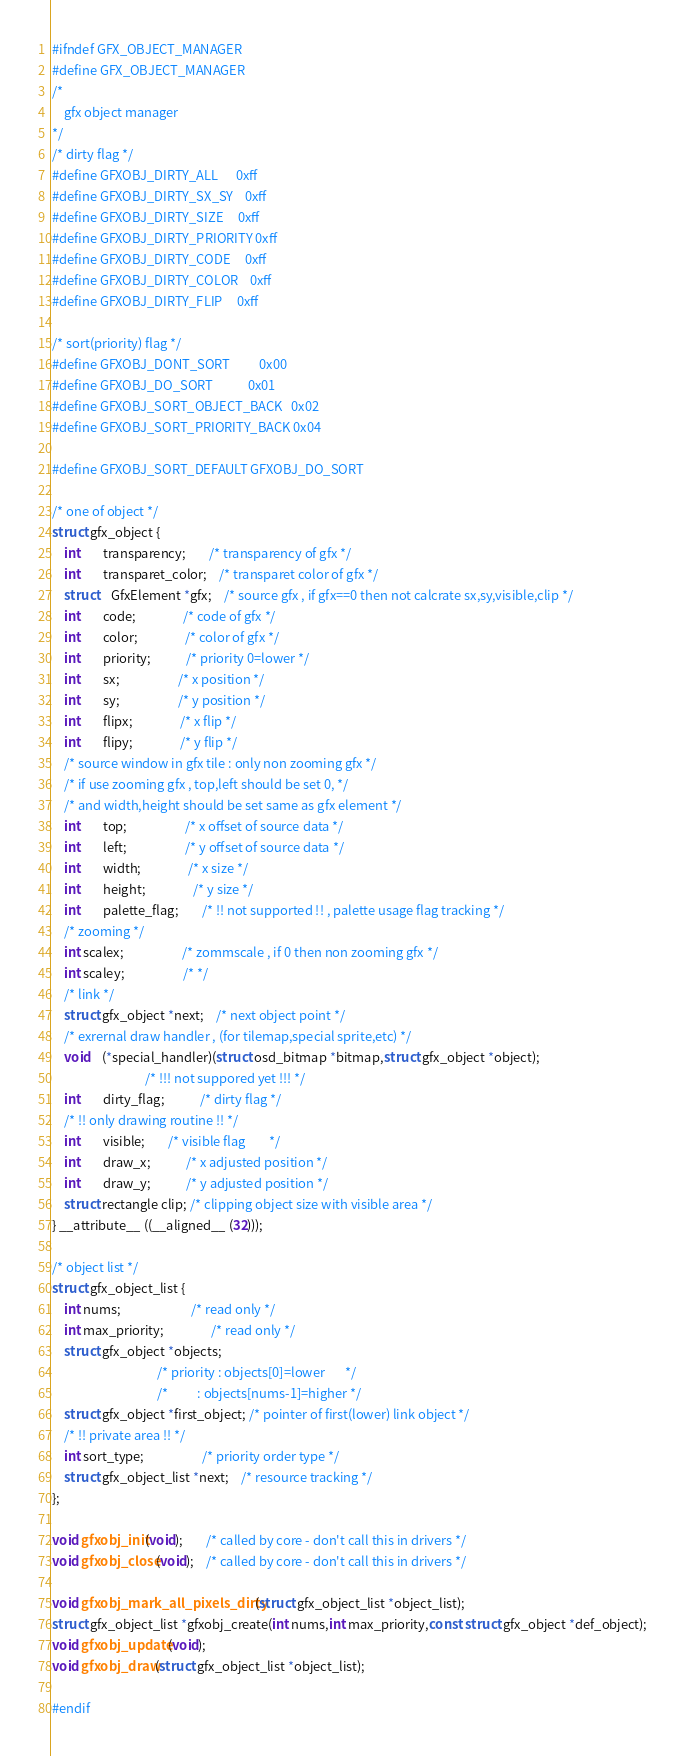Convert code to text. <code><loc_0><loc_0><loc_500><loc_500><_C_>#ifndef GFX_OBJECT_MANAGER
#define GFX_OBJECT_MANAGER
/*
	gfx object manager
*/
/* dirty flag */
#define GFXOBJ_DIRTY_ALL      0xff
#define GFXOBJ_DIRTY_SX_SY    0xff
#define GFXOBJ_DIRTY_SIZE     0xff
#define GFXOBJ_DIRTY_PRIORITY 0xff
#define GFXOBJ_DIRTY_CODE     0xff
#define GFXOBJ_DIRTY_COLOR    0xff
#define GFXOBJ_DIRTY_FLIP     0xff

/* sort(priority) flag */
#define GFXOBJ_DONT_SORT          0x00
#define GFXOBJ_DO_SORT            0x01
#define GFXOBJ_SORT_OBJECT_BACK   0x02
#define GFXOBJ_SORT_PRIORITY_BACK 0x04

#define GFXOBJ_SORT_DEFAULT GFXOBJ_DO_SORT

/* one of object */
struct gfx_object {
	int		transparency;		/* transparency of gfx */
	int		transparet_color;	/* transparet color of gfx */
	struct	GfxElement *gfx;	/* source gfx , if gfx==0 then not calcrate sx,sy,visible,clip */
	int		code;				/* code of gfx */
	int		color;				/* color of gfx */
	int		priority;			/* priority 0=lower */
	int		sx;					/* x position */
	int		sy;					/* y position */
	int		flipx;				/* x flip */
	int		flipy;				/* y flip */
	/* source window in gfx tile : only non zooming gfx */
	/* if use zooming gfx , top,left should be set 0, */
	/* and width,height should be set same as gfx element */
	int		top;					/* x offset of source data */
	int		left;					/* y offset of source data */
	int		width;				/* x size */
	int		height;				/* y size */
	int		palette_flag;		/* !! not supported !! , palette usage flag tracking */
	/* zooming */
	int scalex;					/* zommscale , if 0 then non zooming gfx */
	int scaley;					/* */
	/* link */
	struct gfx_object *next;	/* next object point */
	/* exrernal draw handler , (for tilemap,special sprite,etc) */
	void	(*special_handler)(struct osd_bitmap *bitmap,struct gfx_object *object);
								/* !!! not suppored yet !!! */
	int		dirty_flag;			/* dirty flag */
	/* !! only drawing routine !! */
	int		visible;		/* visible flag        */
	int		draw_x;			/* x adjusted position */
	int		draw_y;			/* y adjusted position */
	struct rectangle clip; /* clipping object size with visible area */
} __attribute__ ((__aligned__ (32)));

/* object list */
struct gfx_object_list {
	int nums;						/* read only */
	int max_priority;				/* read only */
	struct gfx_object *objects;
									/* priority : objects[0]=lower       */
									/*          : objects[nums-1]=higher */
	struct gfx_object *first_object; /* pointer of first(lower) link object */
	/* !! private area !! */
	int sort_type;					/* priority order type */
	struct gfx_object_list *next;	/* resource tracking */
};

void gfxobj_init(void);		/* called by core - don't call this in drivers */
void gfxobj_close(void);	/* called by core - don't call this in drivers */

void gfxobj_mark_all_pixels_dirty(struct gfx_object_list *object_list);
struct gfx_object_list *gfxobj_create(int nums,int max_priority,const struct gfx_object *def_object);
void gfxobj_update(void);
void gfxobj_draw(struct gfx_object_list *object_list);

#endif
</code> 